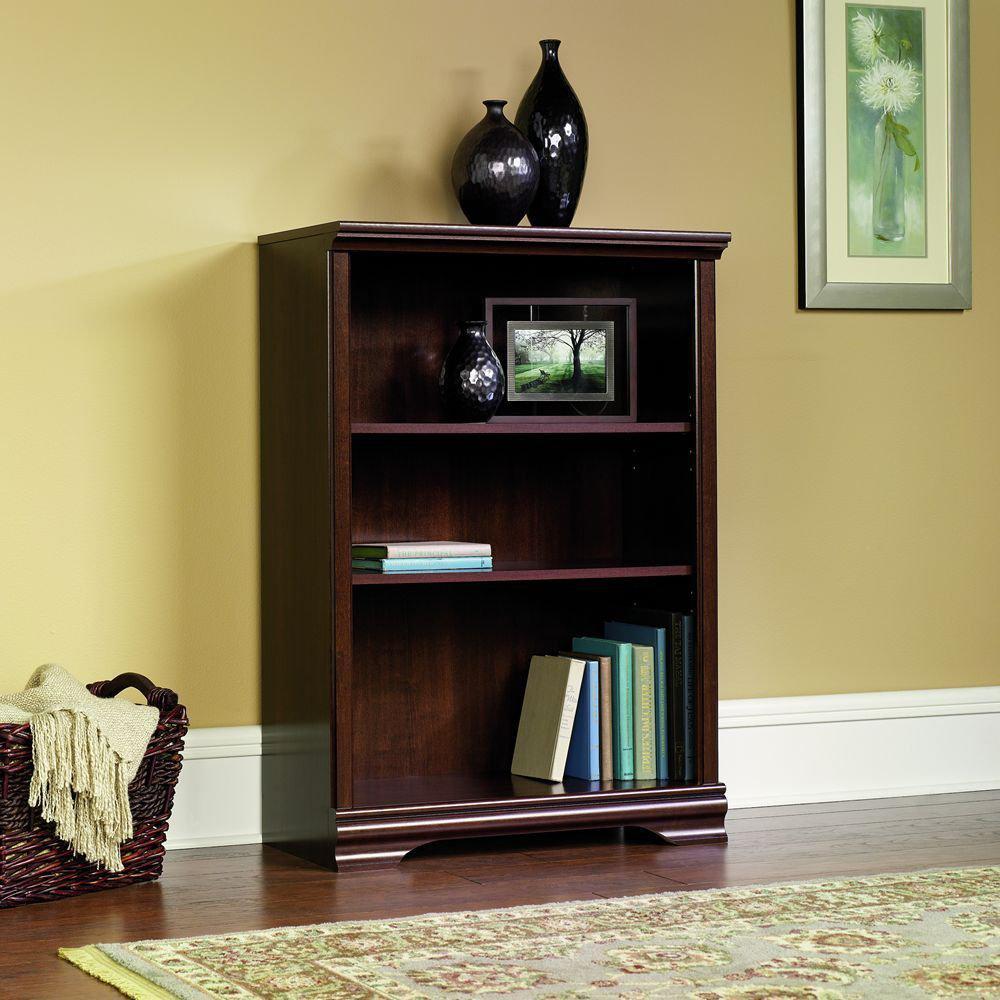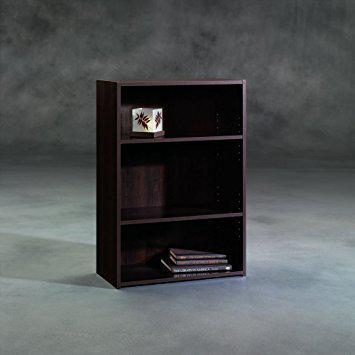The first image is the image on the left, the second image is the image on the right. For the images shown, is this caption "Both bookcases have three shelves." true? Answer yes or no. Yes. The first image is the image on the left, the second image is the image on the right. Assess this claim about the two images: "Each bookcase has a solid back and exactly three shelves, and one bookcase has two items side-by-side on its top, while the other has an empty top.". Correct or not? Answer yes or no. Yes. 